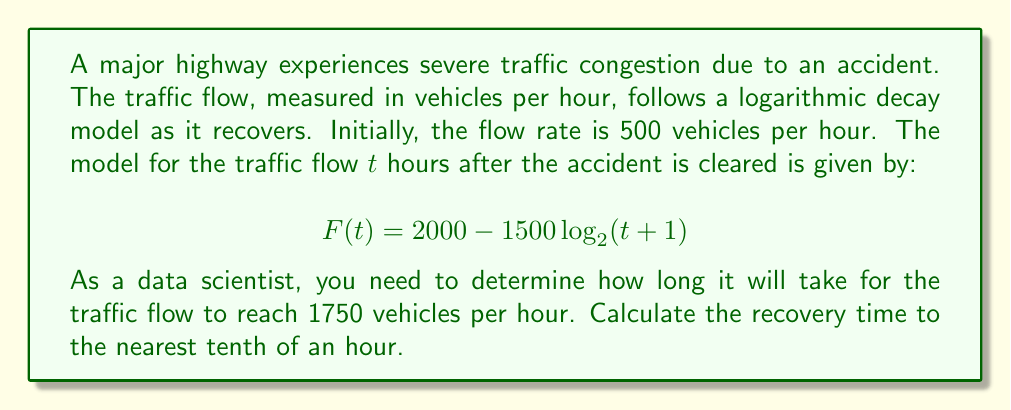Help me with this question. To solve this problem, we need to follow these steps:

1) We are looking for the time $t$ when $F(t) = 1750$. Let's set up the equation:

   $$1750 = 2000 - 1500 \log_2(t+1)$$

2) Subtract 2000 from both sides:

   $$-250 = -1500 \log_2(t+1)$$

3) Divide both sides by -1500:

   $$\frac{1}{6} = \log_2(t+1)$$

4) Now, we need to apply the inverse function (exponential) to both sides. Since the base is 2, we use $2^x$:

   $$2^{\frac{1}{6}} = t+1$$

5) Subtract 1 from both sides:

   $$2^{\frac{1}{6}} - 1 = t$$

6) Calculate this value:

   $$t = 2^{\frac{1}{6}} - 1 \approx 1.1225 - 1 = 0.1225$$

7) Rounding to the nearest tenth:

   $$t \approx 0.1$$

Therefore, it will take approximately 0.1 hours (or 6 minutes) for the traffic flow to reach 1750 vehicles per hour.
Answer: 0.1 hours 